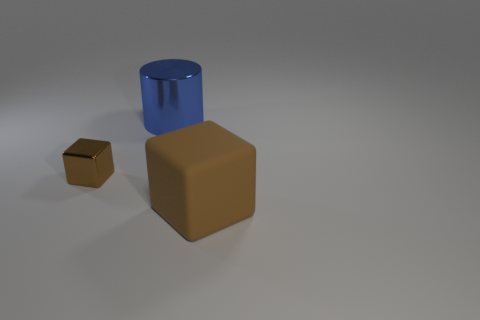Is the material of the object that is on the left side of the cylinder the same as the large cube?
Make the answer very short. No. Are there fewer big rubber cubes that are in front of the big rubber block than small shiny things?
Provide a short and direct response. Yes. The rubber thing that is the same size as the blue metal cylinder is what color?
Keep it short and to the point. Brown. How many tiny brown metallic things are the same shape as the blue metallic thing?
Your response must be concise. 0. There is a big object that is behind the small brown shiny cube; what is its color?
Provide a succinct answer. Blue. How many matte objects are purple cubes or tiny brown cubes?
Offer a very short reply. 0. There is another object that is the same color as the tiny thing; what is its shape?
Keep it short and to the point. Cube. How many brown metallic objects are the same size as the brown metal cube?
Give a very brief answer. 0. There is a object that is both in front of the big blue metal cylinder and left of the big brown rubber object; what color is it?
Offer a terse response. Brown. What number of objects are large green shiny things or cylinders?
Offer a very short reply. 1. 